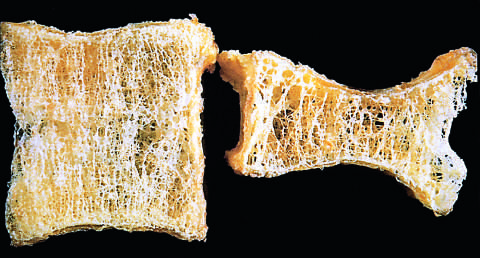s high-power detail of an asbestos body shorten by compression fractures?
Answer the question using a single word or phrase. No 